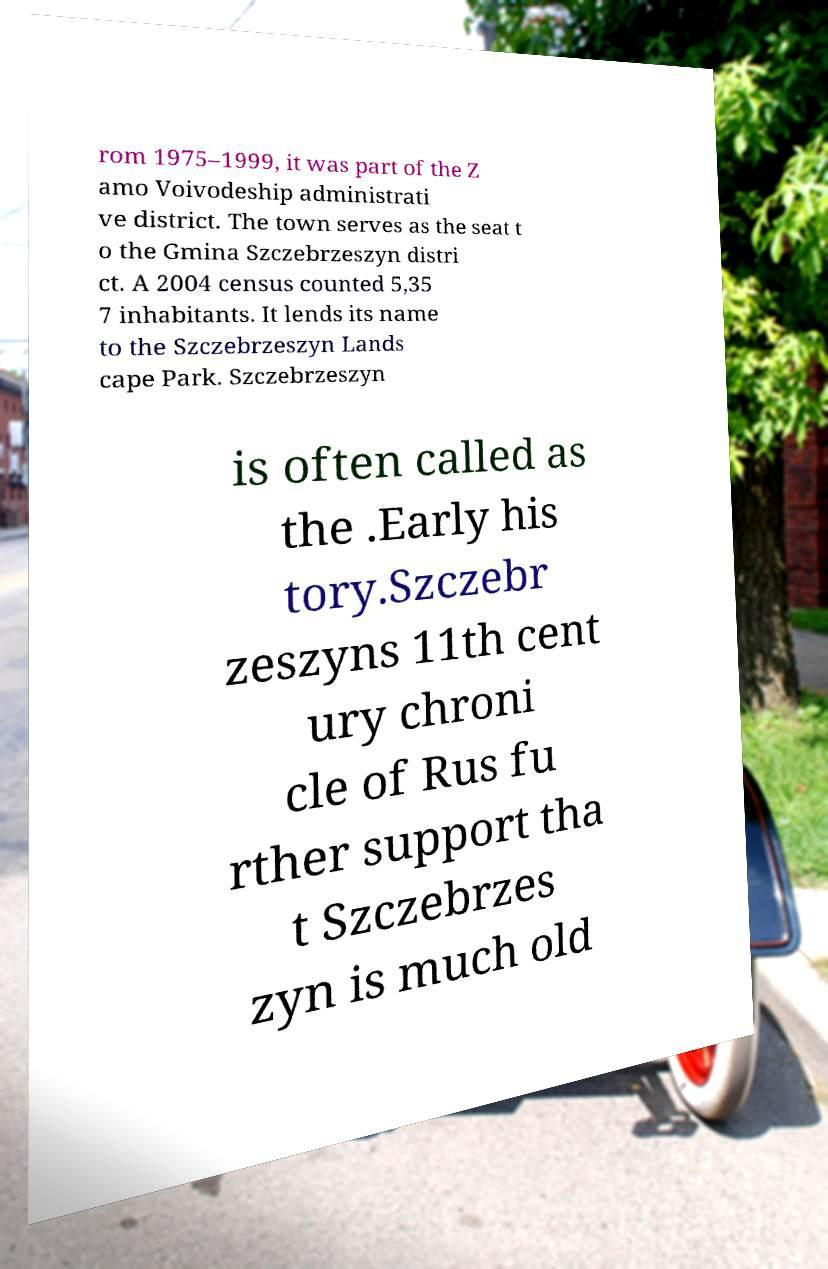I need the written content from this picture converted into text. Can you do that? rom 1975–1999, it was part of the Z amo Voivodeship administrati ve district. The town serves as the seat t o the Gmina Szczebrzeszyn distri ct. A 2004 census counted 5,35 7 inhabitants. It lends its name to the Szczebrzeszyn Lands cape Park. Szczebrzeszyn is often called as the .Early his tory.Szczebr zeszyns 11th cent ury chroni cle of Rus fu rther support tha t Szczebrzes zyn is much old 